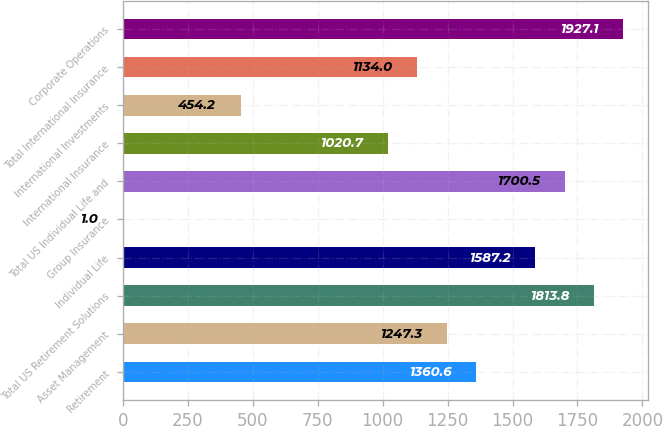Convert chart. <chart><loc_0><loc_0><loc_500><loc_500><bar_chart><fcel>Retirement<fcel>Asset Management<fcel>Total US Retirement Solutions<fcel>Individual Life<fcel>Group Insurance<fcel>Total US Individual Life and<fcel>International Insurance<fcel>International Investments<fcel>Total International Insurance<fcel>Corporate Operations<nl><fcel>1360.6<fcel>1247.3<fcel>1813.8<fcel>1587.2<fcel>1<fcel>1700.5<fcel>1020.7<fcel>454.2<fcel>1134<fcel>1927.1<nl></chart> 